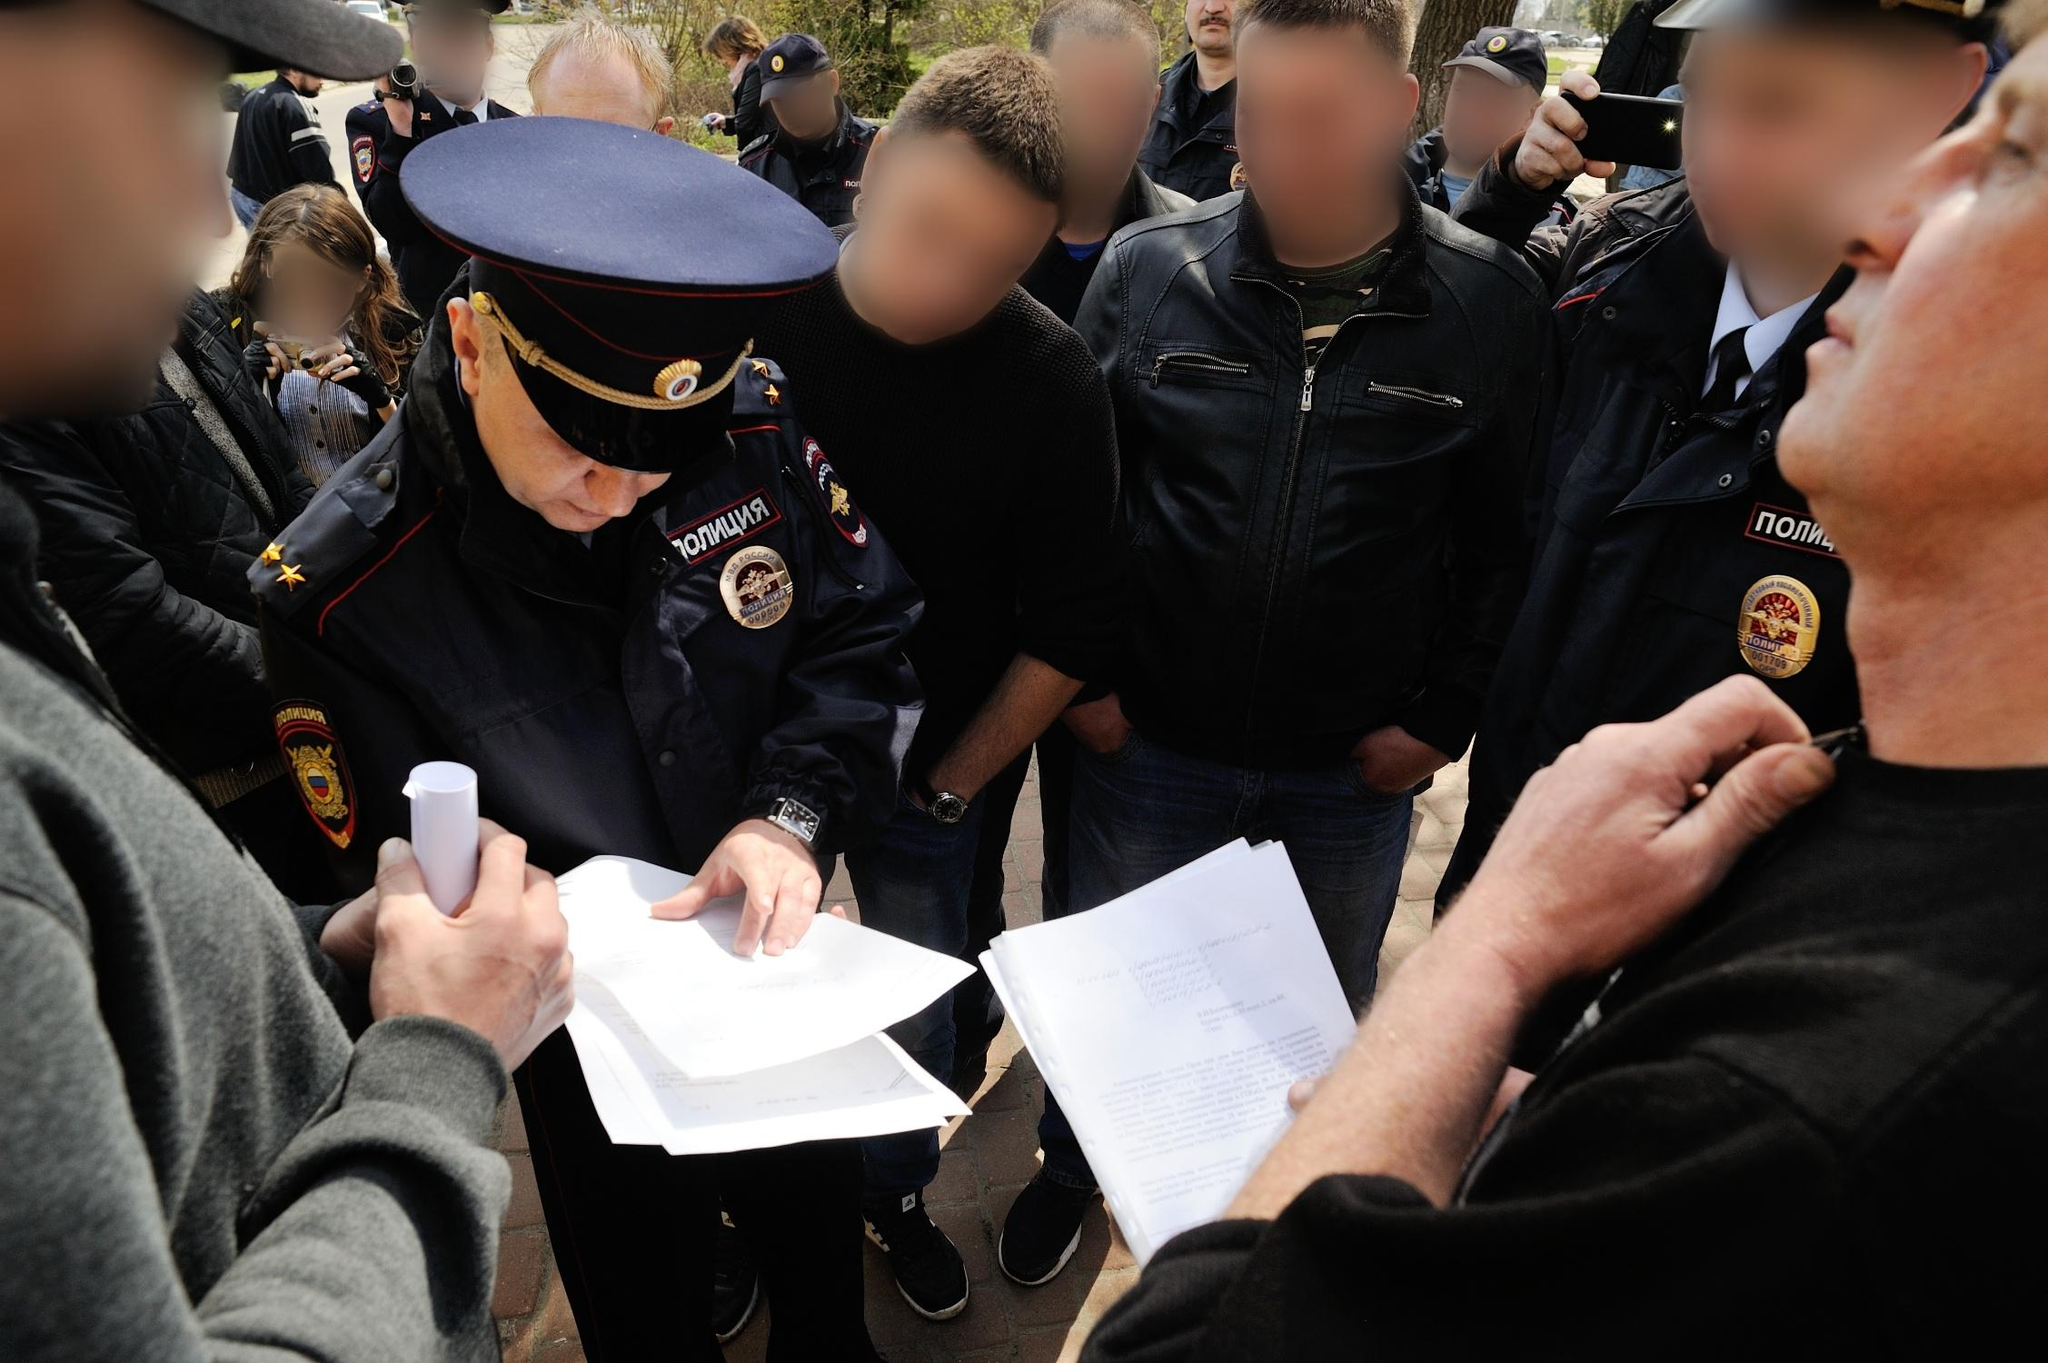What if this scene was part of a historical moment, what could be the context? This moment could be part of a significant historical event, such as a crucial public declaration or the enforcement of a new policy. The officer might be documenting the names of participants in a post-protest gathering, or recording witness statements for an important civic event. The manner of the gathering, along with the serious demeanor of the officer, suggests an event where maintaining order and accurate records is paramount. The uniforms, indicative of law enforcement, align with historical scenes of public administration or civil service during critical junctures in history. 